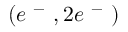<formula> <loc_0><loc_0><loc_500><loc_500>( e ^ { - } , 2 e ^ { - } )</formula> 